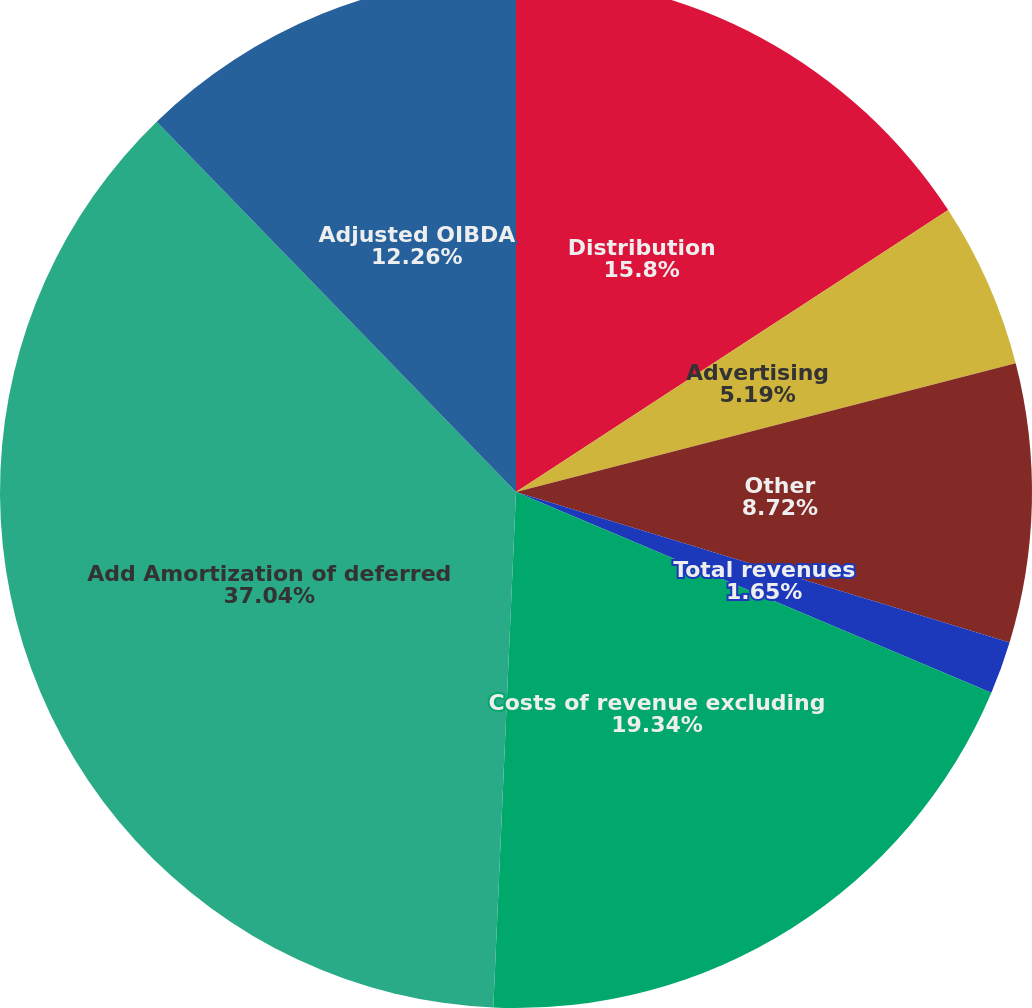Convert chart. <chart><loc_0><loc_0><loc_500><loc_500><pie_chart><fcel>Distribution<fcel>Advertising<fcel>Other<fcel>Total revenues<fcel>Costs of revenue excluding<fcel>Add Amortization of deferred<fcel>Adjusted OIBDA<nl><fcel>15.8%<fcel>5.19%<fcel>8.72%<fcel>1.65%<fcel>19.34%<fcel>37.04%<fcel>12.26%<nl></chart> 